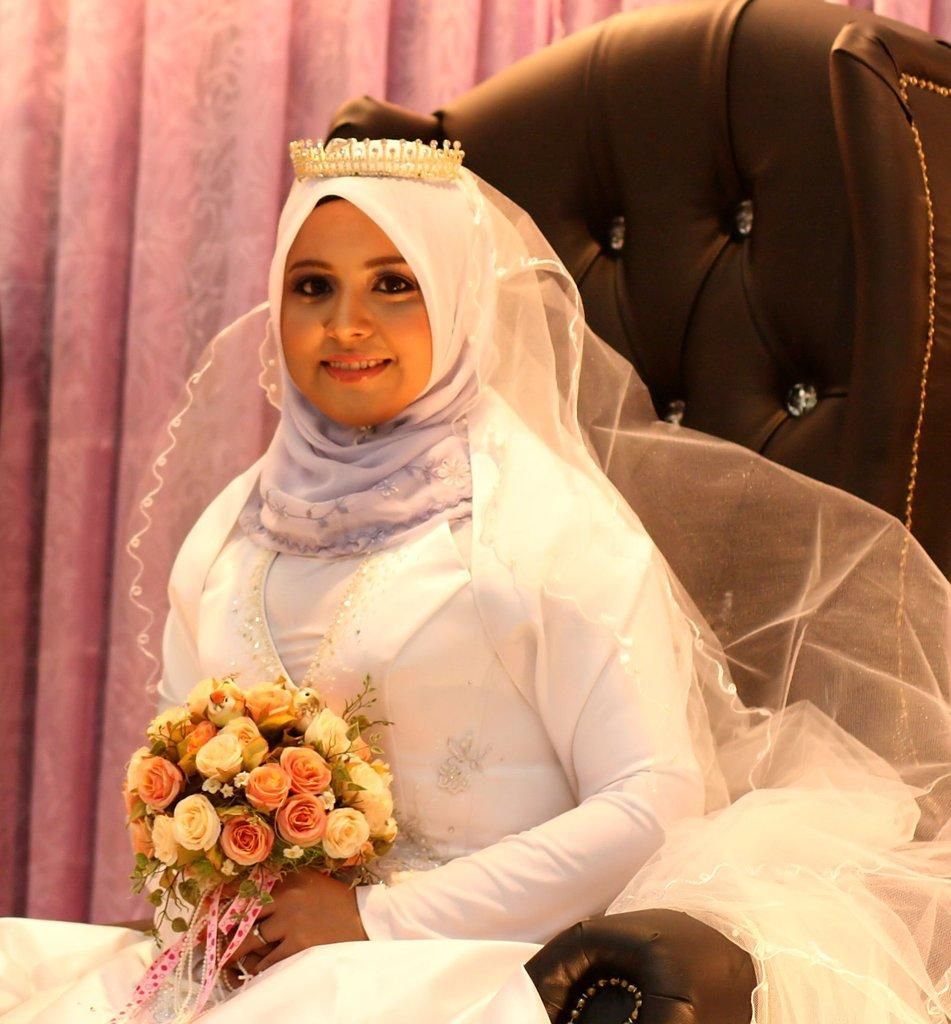Who is present in the image? There is a woman in the image. What is the woman doing in the image? The woman is sitting on a chair and holding a bouquet. What can be seen in the background of the image? There is a curtain in the background of the image. What type of egg is being used to make the eggnog in the image? There is no egg or eggnog present in the image; it features a woman sitting on a chair and holding a bouquet. What is the woman using to listen to music in the image? There is no mention of music or ear-related items in the image; the woman is holding a bouquet. 